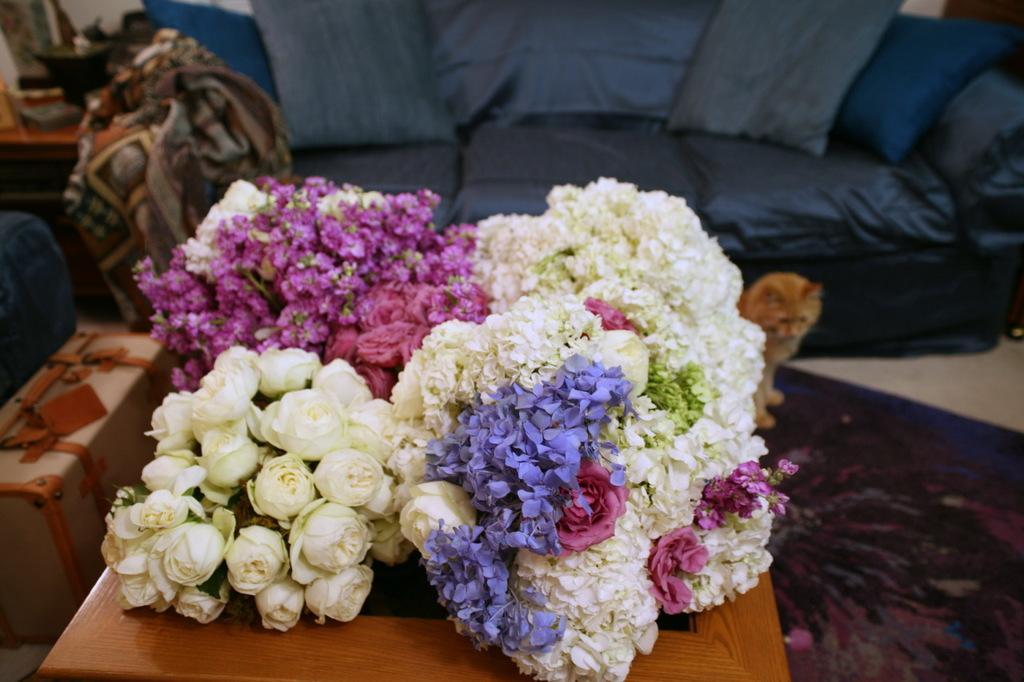In one or two sentences, can you explain what this image depicts? In this image in the center there are some flowers, on a table and in the background there is a couch. On the couch there are pillows and one cat, and on the left side there are suitcases and table and some objects. And on the couch there is one blanket, at the bottom there is floor. On the floor there is carpet. 